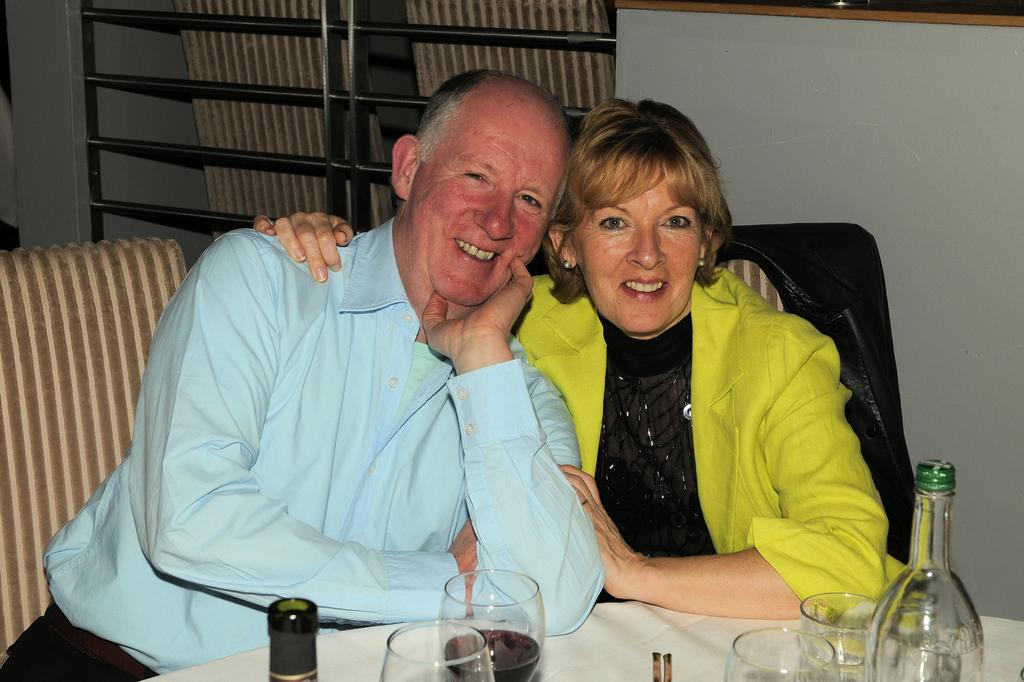Who is present in the image? A: There is a man and a woman in the image. What are the man and woman doing in the image? The man and woman are sitting on chairs. Where are the chairs located in relation to the dining table? The chairs are near a dining table. What can be seen on the dining table? There are glasses and a bottle on the table. What type of trouble is the sheep causing with its thumb in the image? There is no sheep or thumb present in the image. 